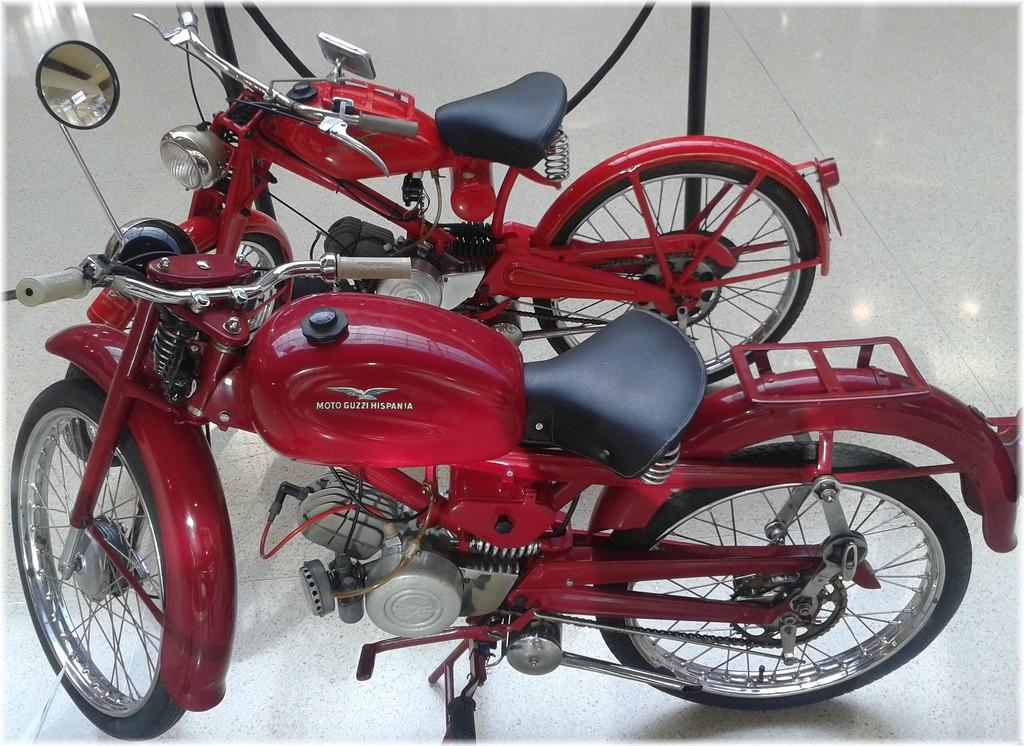Where was the image taken? The image is taken indoors. What can be seen under the bikes in the image? There is a floor visible in the image. How many bikes are parked in the image? Two bikes are parked in the middle of the image. What color are the bikes? The bikes are red in color. Which direction is the airport located from the bikes in the image? There is no airport present in the image, so it is not possible to determine its direction from the bikes. 